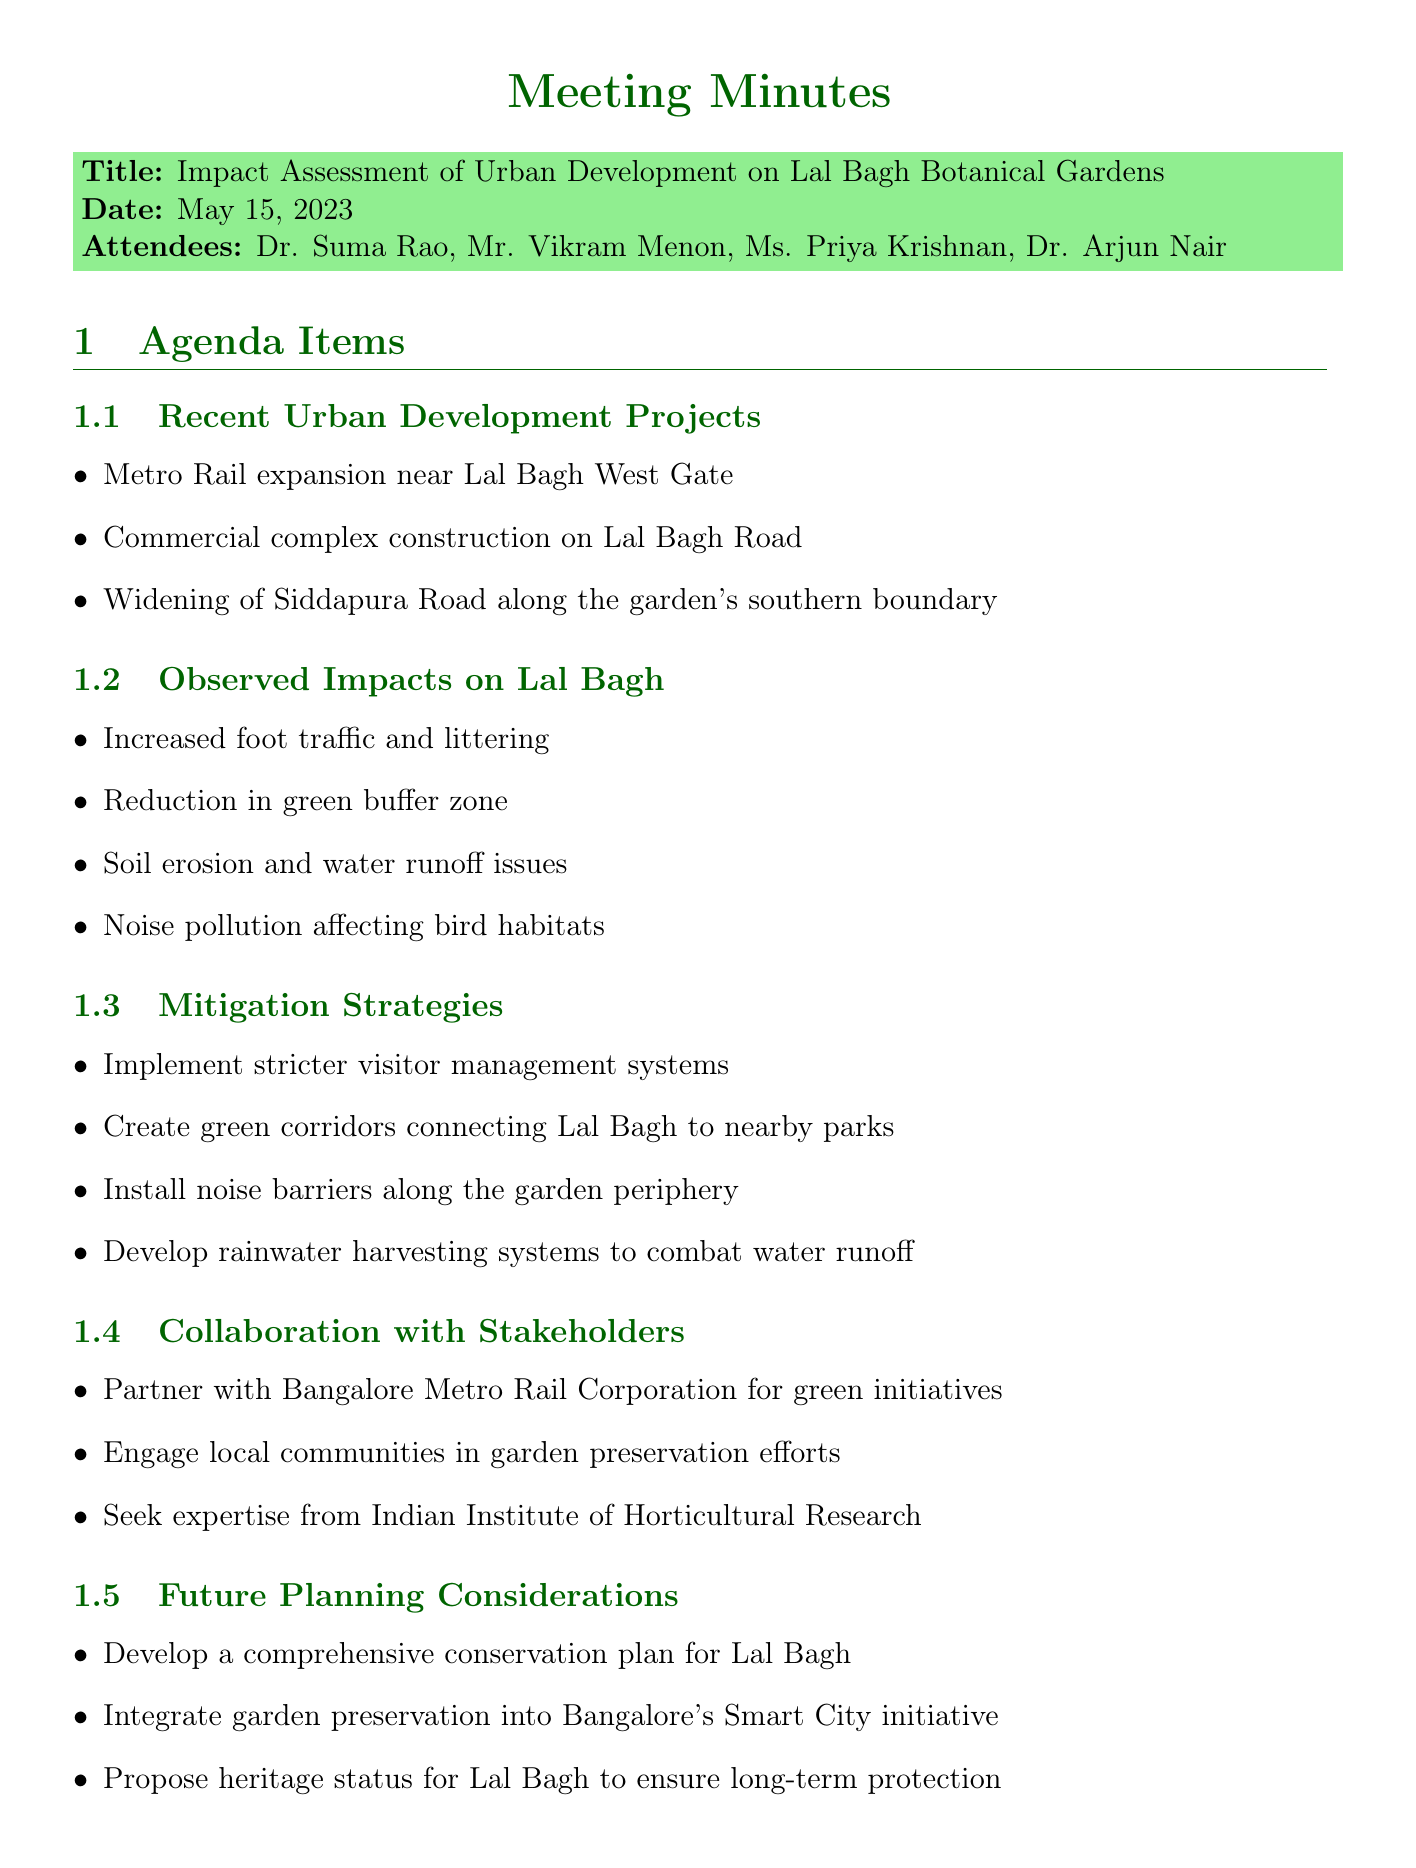What is the meeting title? The meeting title is categorized under the "Title" section of the document.
Answer: Impact Assessment of Urban Development on Lal Bagh Botanical Gardens Who attended the meeting? The attendees are listed under the "Attendees" section in the document.
Answer: Dr. Suma Rao, Mr. Vikram Menon, Ms. Priya Krishnan, Dr. Arjun Nair What is one observed impact on Lal Bagh? The "Observed Impacts on Lal Bagh" section contains specific points outlining these impacts.
Answer: Increased foot traffic and littering What mitigation strategy involves local communities? The "Mitigation Strategies" section includes various strategies to address negative impacts, including community engagement.
Answer: Engage local communities in garden preservation efforts When is the next meeting scheduled? The next meeting date is provided in the last section of the document.
Answer: June 15, 2023 What kind of pollution is affecting bird habitats? The type of pollution affecting bird habitats is specified in the "Observed Impacts on Lal Bagh" section.
Answer: Noise pollution affecting bird habitats Who is responsible for drafting the impact assessment report? This responsibility is mentioned in the "Action Items" section of the document.
Answer: Dr. Suma Rao What project is related to the Metro Rail? The document lists related urban development projects under the "Recent Urban Development Projects" section.
Answer: Metro Rail expansion near Lal Bagh West Gate What is being proposed for Lal Bagh to ensure long-term protection? The "Future Planning Considerations" section includes proposals related to Lal Bagh's conservation.
Answer: Propose heritage status for Lal Bagh to ensure long-term protection 